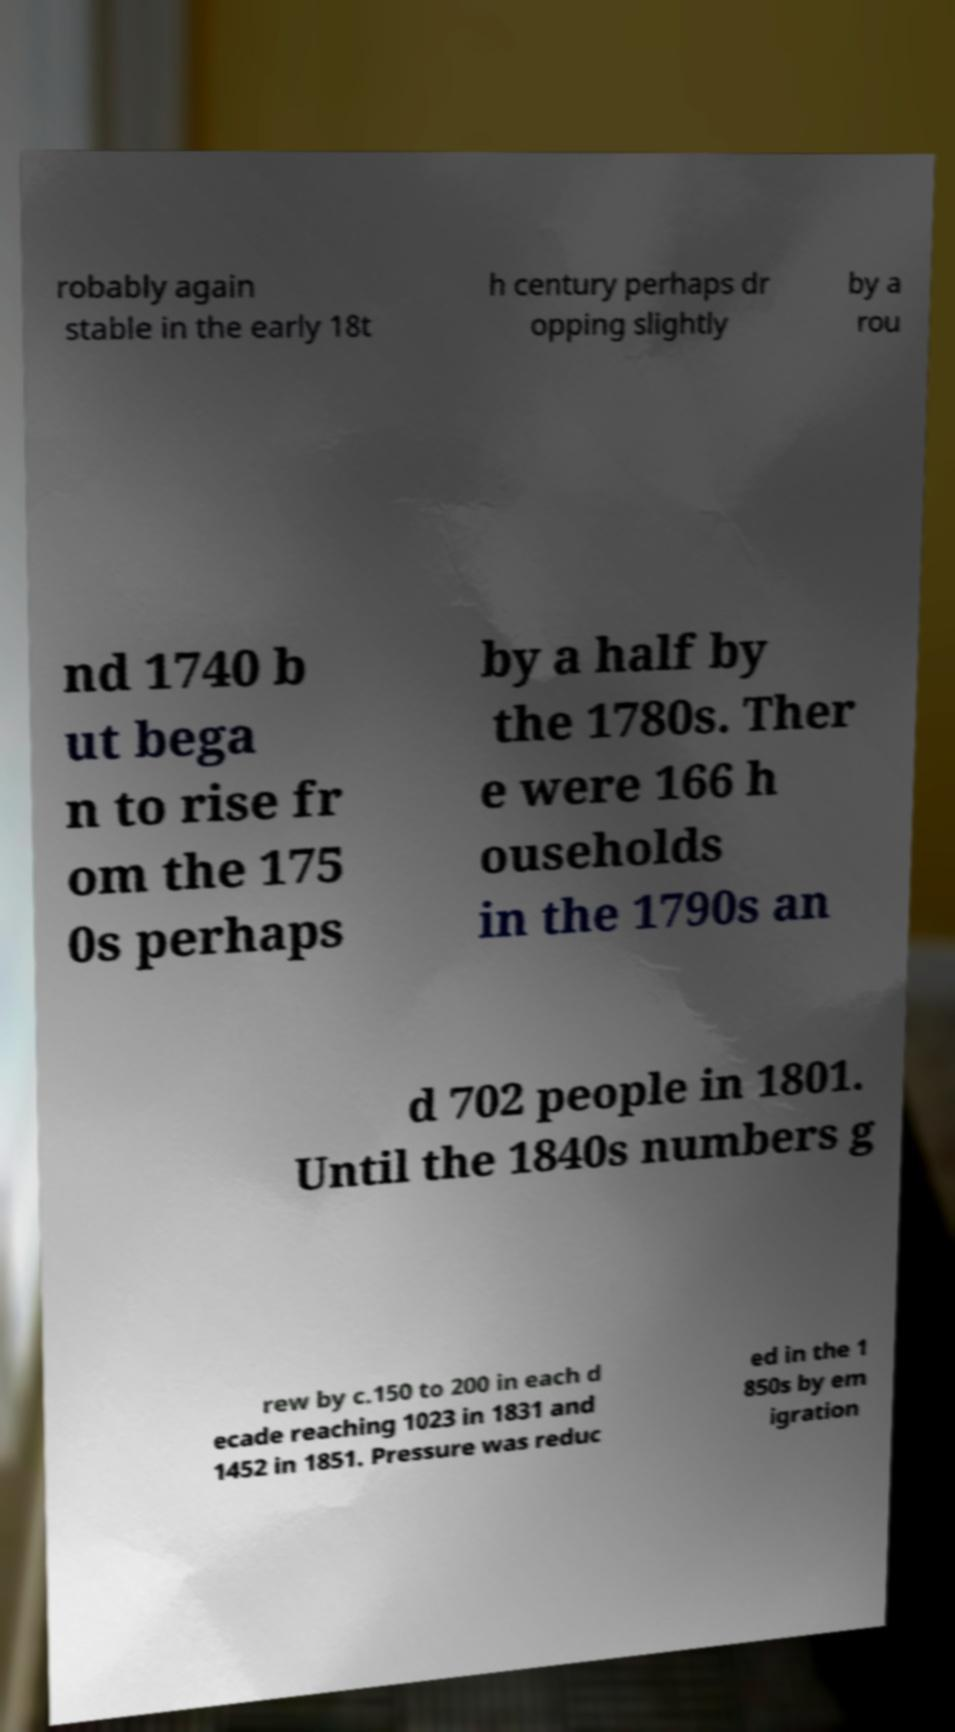Please identify and transcribe the text found in this image. robably again stable in the early 18t h century perhaps dr opping slightly by a rou nd 1740 b ut bega n to rise fr om the 175 0s perhaps by a half by the 1780s. Ther e were 166 h ouseholds in the 1790s an d 702 people in 1801. Until the 1840s numbers g rew by c.150 to 200 in each d ecade reaching 1023 in 1831 and 1452 in 1851. Pressure was reduc ed in the 1 850s by em igration 